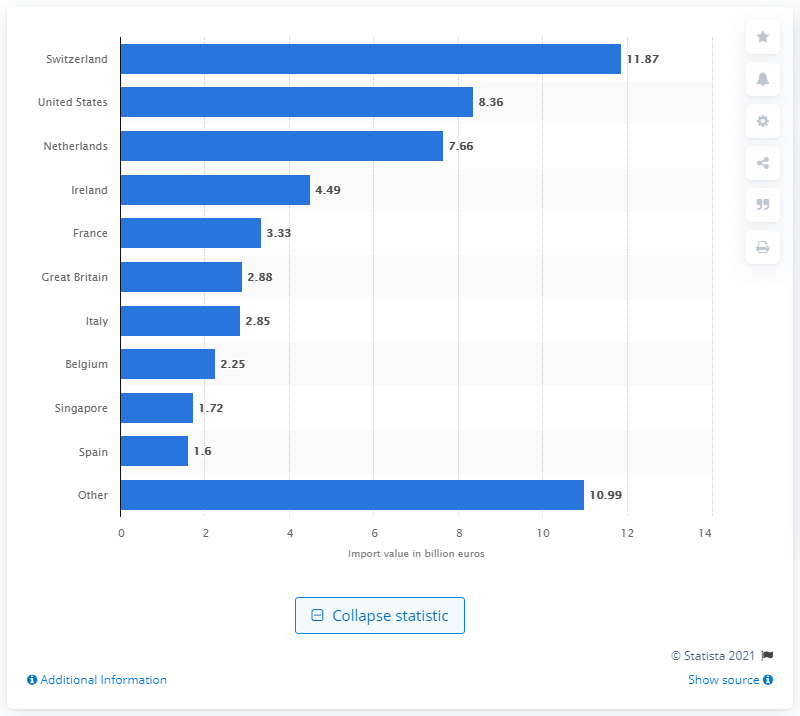Point out several critical features in this image. In 2019, Switzerland was the leading pharmaceutical supplier to Germany. 